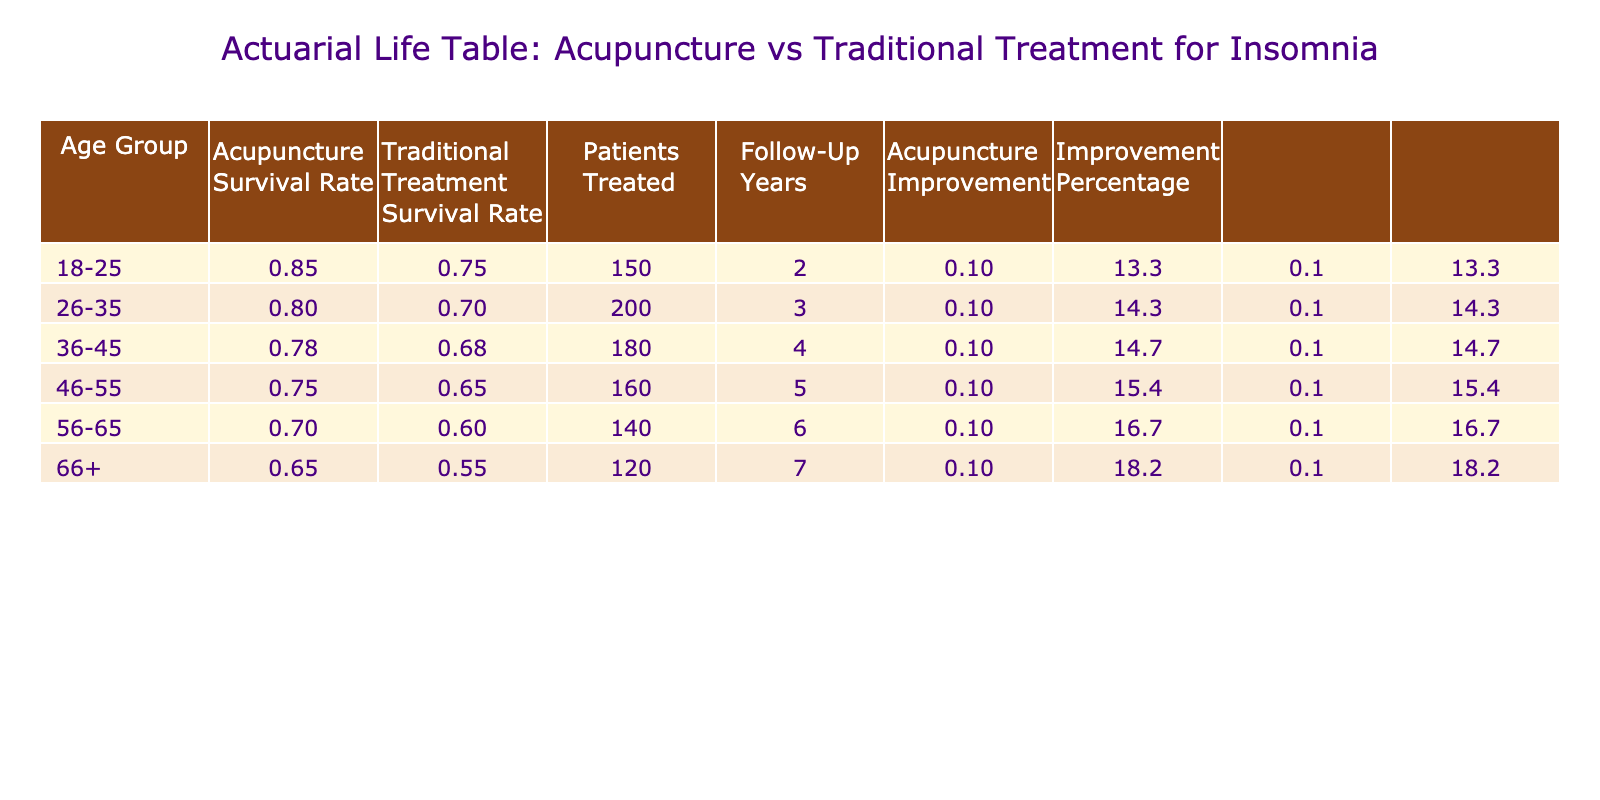What is the survival rate for acupuncture patients in the 36-45 age group? According to the table, the survival rate for acupuncture-treated patients in the 36-45 age group is listed as 0.78.
Answer: 0.78 What is the survival rate for patients who received traditional treatment in the 56-65 age group? The table indicates that the survival rate for traditional treatment patients in the 56-65 age group is 0.60.
Answer: 0.60 In which age group did acupuncture show the highest improvement over traditional treatments? To find this, I compare the improvement values calculated as Acupuncture Survival Rate minus Traditional Treatment Survival Rate. The highest improvement is in the 18-25 age group with 0.85 - 0.75 = 0.10.
Answer: 18-25 What is the average traditional treatment survival rate across all age groups? I can calculate the average by summing the survival rates (0.75 + 0.70 + 0.68 + 0.65 + 0.60 + 0.55) which equals 4.03, then divide by the number of age groups (6). 4.03 / 6 = 0.67167, rounding gives approximately 0.67.
Answer: 0.67 Is the survival rate higher for acupuncture patients aged 66 and above compared to traditional treatments? From the table, acupuncture survival rate for those aged 66+ is 0.65, while traditional treatment survival rate is 0.55. Since 0.65 is greater than 0.55, the statement is true.
Answer: Yes What is the total number of patients treated with acupuncture across all age groups? The total can be found by adding all the patients treated with acupuncture: 150 + 200 + 180 + 160 + 140 + 120, which sums to 1,050.
Answer: 1,050 Which age group has the lowest survival rate for traditional treatments? By checking the survival rates for traditional treatments across the age groups, the lowest is 0.55 in the 66+ age group.
Answer: 66+ What percentage improvement does acupuncture show compared to traditional treatment for the 46-55 age group? The improvement percentage is calculated by taking the improvement (0.75 - 0.65 = 0.10), dividing by the traditional treatment survival rate (0.65), then multiplying by 100 to get the percentage: (0.10 / 0.65) * 100 = 15.38. Thus, approximately 15.4% improvement.
Answer: 15.4% 